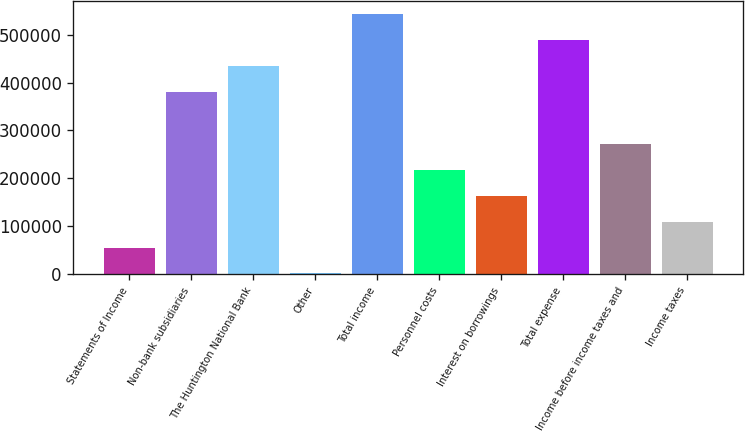Convert chart. <chart><loc_0><loc_0><loc_500><loc_500><bar_chart><fcel>Statements of Income<fcel>Non-bank subsidiaries<fcel>The Huntington National Bank<fcel>Other<fcel>Total income<fcel>Personnel costs<fcel>Interest on borrowings<fcel>Total expense<fcel>Income before income taxes and<fcel>Income taxes<nl><fcel>55369.2<fcel>380198<fcel>434337<fcel>1231<fcel>542613<fcel>217784<fcel>163646<fcel>488475<fcel>271922<fcel>109507<nl></chart> 